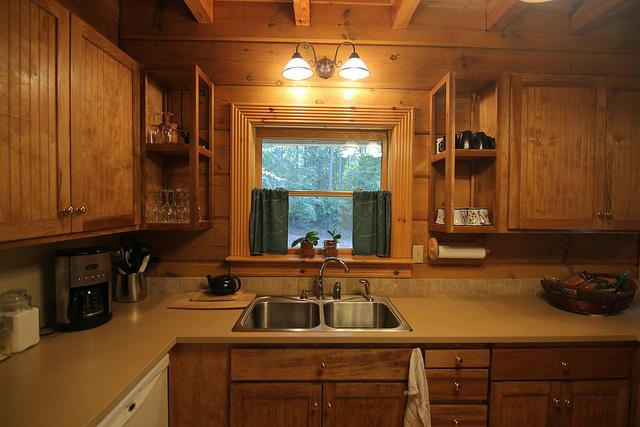What kind of sink is this? kitchen 